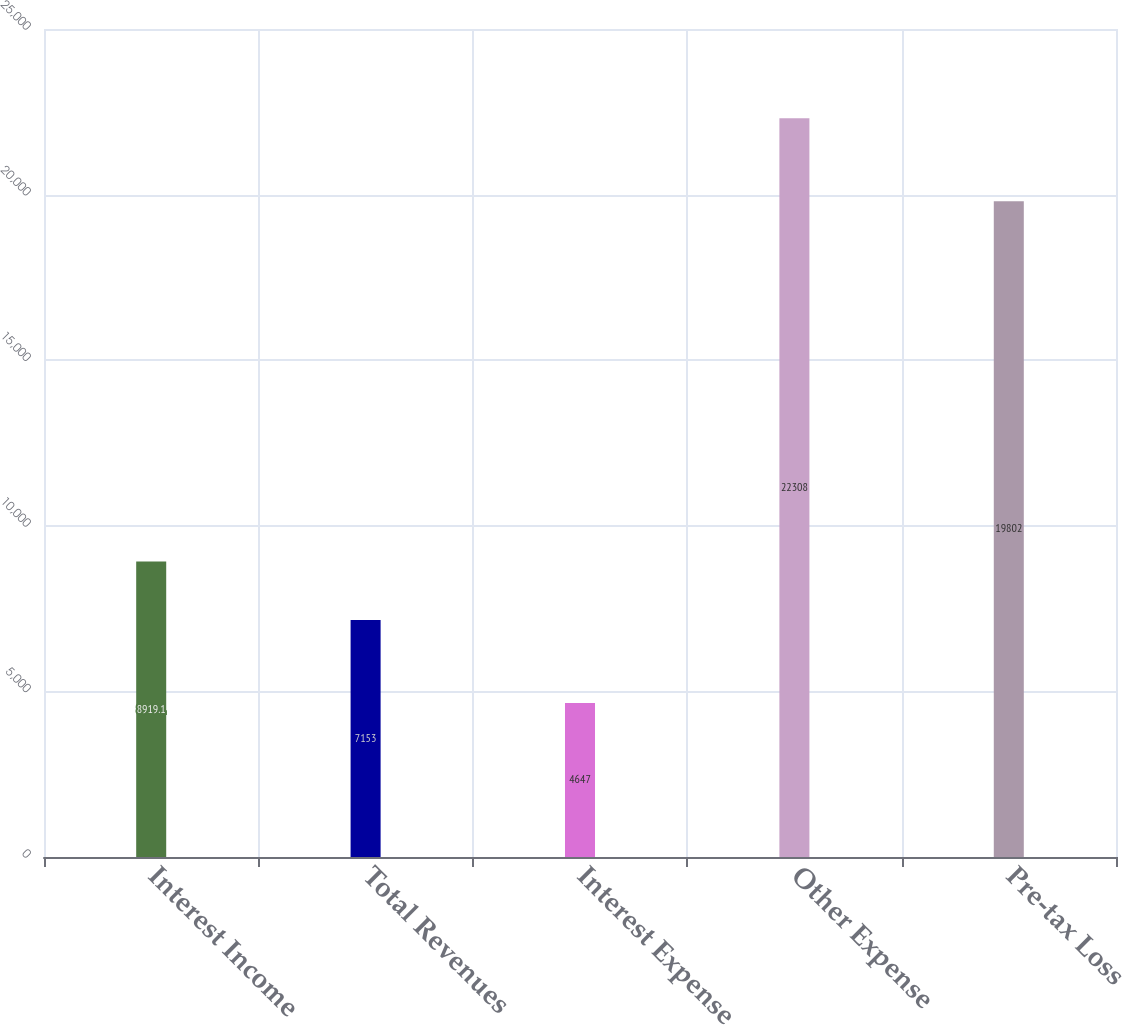<chart> <loc_0><loc_0><loc_500><loc_500><bar_chart><fcel>Interest Income<fcel>Total Revenues<fcel>Interest Expense<fcel>Other Expense<fcel>Pre-tax Loss<nl><fcel>8919.1<fcel>7153<fcel>4647<fcel>22308<fcel>19802<nl></chart> 